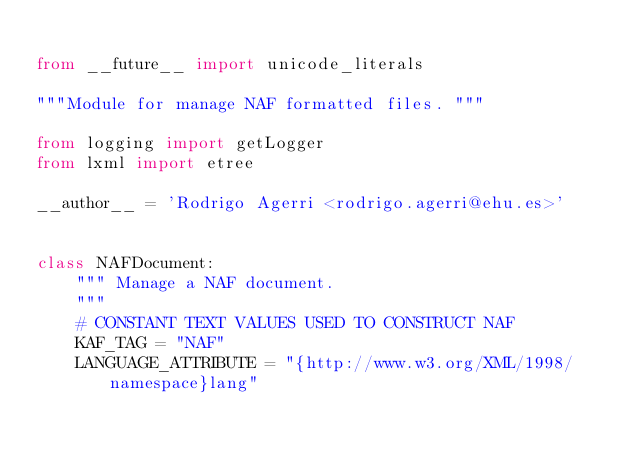<code> <loc_0><loc_0><loc_500><loc_500><_Python_>
from __future__ import unicode_literals

"""Module for manage NAF formatted files. """

from logging import getLogger
from lxml import etree

__author__ = 'Rodrigo Agerri <rodrigo.agerri@ehu.es>'


class NAFDocument:
    """ Manage a NAF document.
    """
    # CONSTANT TEXT VALUES USED TO CONSTRUCT NAF
    KAF_TAG = "NAF"
    LANGUAGE_ATTRIBUTE = "{http://www.w3.org/XML/1998/namespace}lang"</code> 